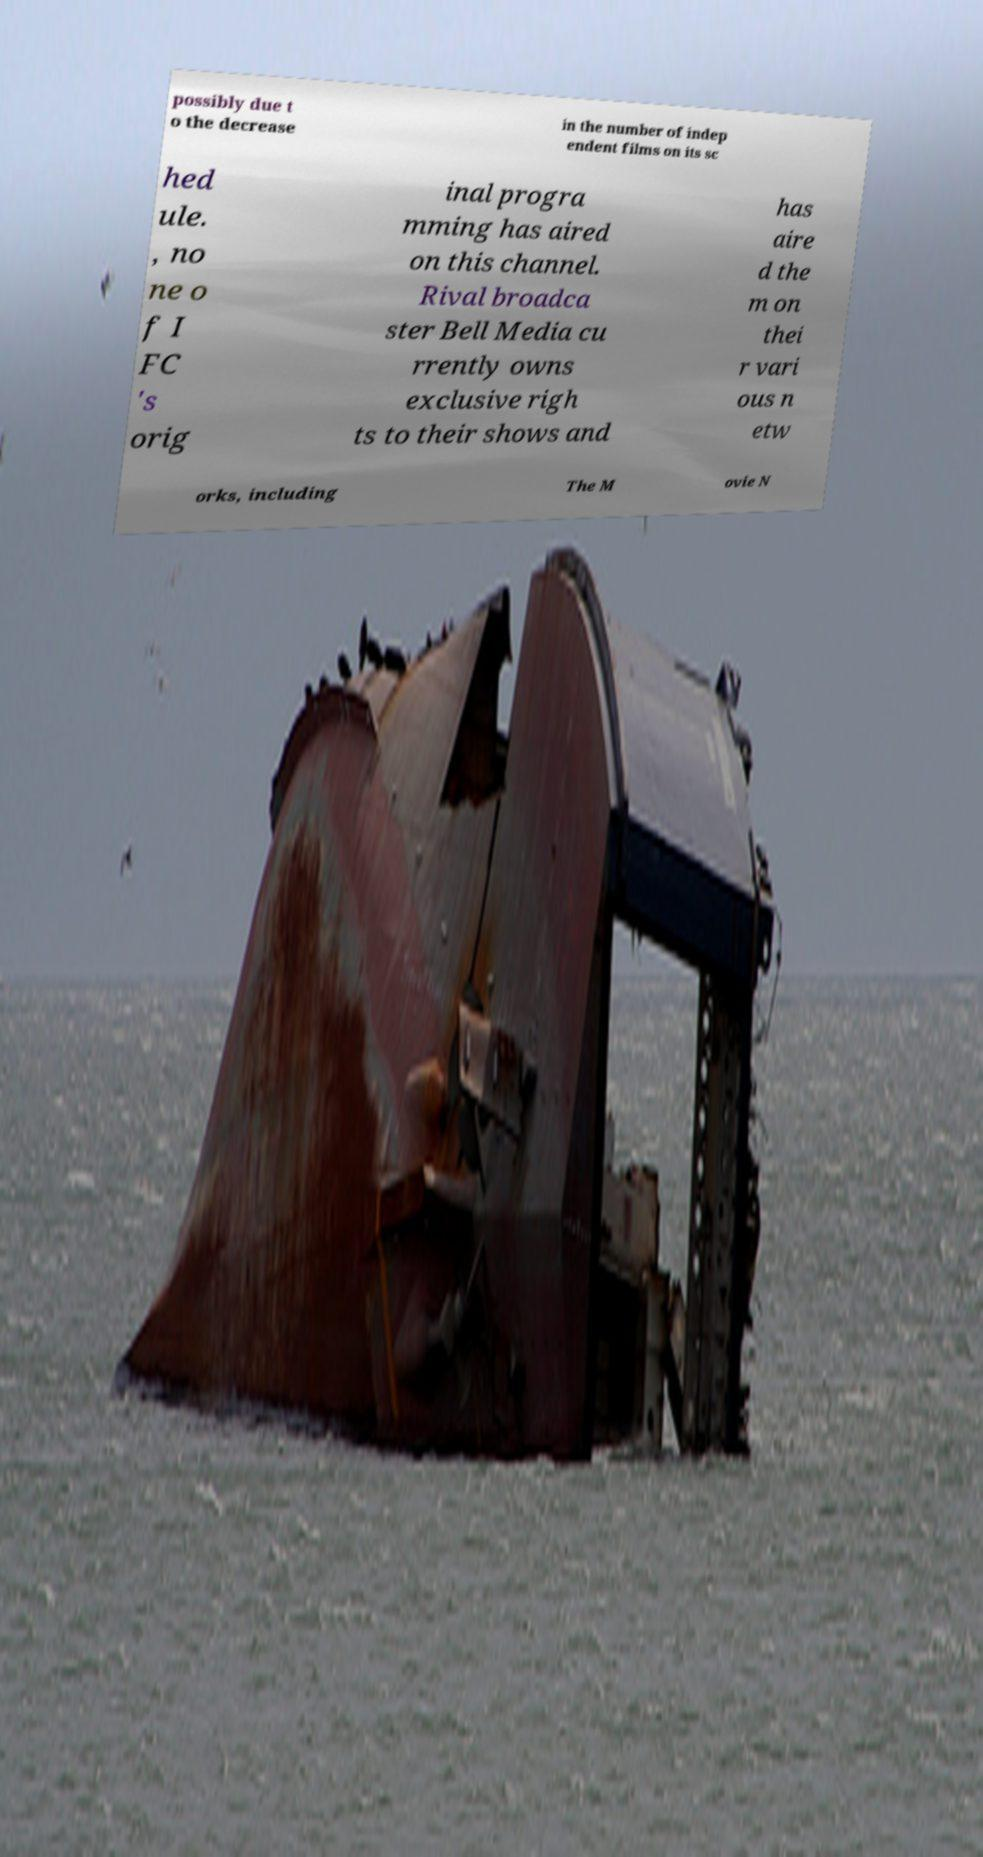I need the written content from this picture converted into text. Can you do that? possibly due t o the decrease in the number of indep endent films on its sc hed ule. , no ne o f I FC 's orig inal progra mming has aired on this channel. Rival broadca ster Bell Media cu rrently owns exclusive righ ts to their shows and has aire d the m on thei r vari ous n etw orks, including The M ovie N 